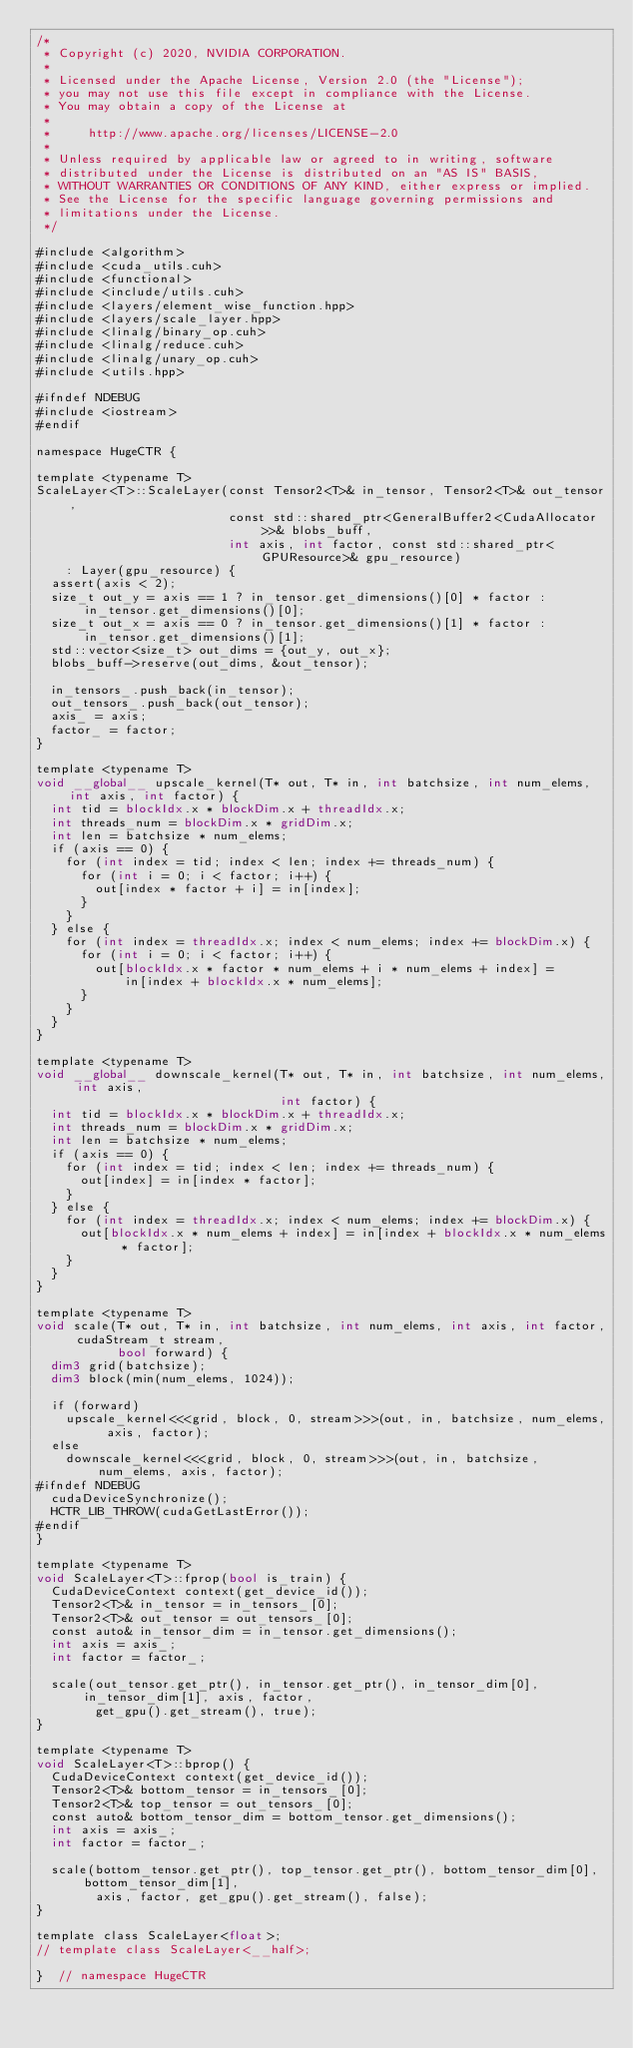Convert code to text. <code><loc_0><loc_0><loc_500><loc_500><_Cuda_>/*
 * Copyright (c) 2020, NVIDIA CORPORATION.
 *
 * Licensed under the Apache License, Version 2.0 (the "License");
 * you may not use this file except in compliance with the License.
 * You may obtain a copy of the License at
 *
 *     http://www.apache.org/licenses/LICENSE-2.0
 *
 * Unless required by applicable law or agreed to in writing, software
 * distributed under the License is distributed on an "AS IS" BASIS,
 * WITHOUT WARRANTIES OR CONDITIONS OF ANY KIND, either express or implied.
 * See the License for the specific language governing permissions and
 * limitations under the License.
 */

#include <algorithm>
#include <cuda_utils.cuh>
#include <functional>
#include <include/utils.cuh>
#include <layers/element_wise_function.hpp>
#include <layers/scale_layer.hpp>
#include <linalg/binary_op.cuh>
#include <linalg/reduce.cuh>
#include <linalg/unary_op.cuh>
#include <utils.hpp>

#ifndef NDEBUG
#include <iostream>
#endif

namespace HugeCTR {

template <typename T>
ScaleLayer<T>::ScaleLayer(const Tensor2<T>& in_tensor, Tensor2<T>& out_tensor,
                          const std::shared_ptr<GeneralBuffer2<CudaAllocator>>& blobs_buff,
                          int axis, int factor, const std::shared_ptr<GPUResource>& gpu_resource)
    : Layer(gpu_resource) {
  assert(axis < 2);
  size_t out_y = axis == 1 ? in_tensor.get_dimensions()[0] * factor : in_tensor.get_dimensions()[0];
  size_t out_x = axis == 0 ? in_tensor.get_dimensions()[1] * factor : in_tensor.get_dimensions()[1];
  std::vector<size_t> out_dims = {out_y, out_x};
  blobs_buff->reserve(out_dims, &out_tensor);

  in_tensors_.push_back(in_tensor);
  out_tensors_.push_back(out_tensor);
  axis_ = axis;
  factor_ = factor;
}

template <typename T>
void __global__ upscale_kernel(T* out, T* in, int batchsize, int num_elems, int axis, int factor) {
  int tid = blockIdx.x * blockDim.x + threadIdx.x;
  int threads_num = blockDim.x * gridDim.x;
  int len = batchsize * num_elems;
  if (axis == 0) {
    for (int index = tid; index < len; index += threads_num) {
      for (int i = 0; i < factor; i++) {
        out[index * factor + i] = in[index];
      }
    }
  } else {
    for (int index = threadIdx.x; index < num_elems; index += blockDim.x) {
      for (int i = 0; i < factor; i++) {
        out[blockIdx.x * factor * num_elems + i * num_elems + index] =
            in[index + blockIdx.x * num_elems];
      }
    }
  }
}

template <typename T>
void __global__ downscale_kernel(T* out, T* in, int batchsize, int num_elems, int axis,
                                 int factor) {
  int tid = blockIdx.x * blockDim.x + threadIdx.x;
  int threads_num = blockDim.x * gridDim.x;
  int len = batchsize * num_elems;
  if (axis == 0) {
    for (int index = tid; index < len; index += threads_num) {
      out[index] = in[index * factor];
    }
  } else {
    for (int index = threadIdx.x; index < num_elems; index += blockDim.x) {
      out[blockIdx.x * num_elems + index] = in[index + blockIdx.x * num_elems * factor];
    }
  }
}

template <typename T>
void scale(T* out, T* in, int batchsize, int num_elems, int axis, int factor, cudaStream_t stream,
           bool forward) {
  dim3 grid(batchsize);
  dim3 block(min(num_elems, 1024));

  if (forward)
    upscale_kernel<<<grid, block, 0, stream>>>(out, in, batchsize, num_elems, axis, factor);
  else
    downscale_kernel<<<grid, block, 0, stream>>>(out, in, batchsize, num_elems, axis, factor);
#ifndef NDEBUG
  cudaDeviceSynchronize();
  HCTR_LIB_THROW(cudaGetLastError());
#endif
}

template <typename T>
void ScaleLayer<T>::fprop(bool is_train) {
  CudaDeviceContext context(get_device_id());
  Tensor2<T>& in_tensor = in_tensors_[0];
  Tensor2<T>& out_tensor = out_tensors_[0];
  const auto& in_tensor_dim = in_tensor.get_dimensions();
  int axis = axis_;
  int factor = factor_;

  scale(out_tensor.get_ptr(), in_tensor.get_ptr(), in_tensor_dim[0], in_tensor_dim[1], axis, factor,
        get_gpu().get_stream(), true);
}

template <typename T>
void ScaleLayer<T>::bprop() {
  CudaDeviceContext context(get_device_id());
  Tensor2<T>& bottom_tensor = in_tensors_[0];
  Tensor2<T>& top_tensor = out_tensors_[0];
  const auto& bottom_tensor_dim = bottom_tensor.get_dimensions();
  int axis = axis_;
  int factor = factor_;

  scale(bottom_tensor.get_ptr(), top_tensor.get_ptr(), bottom_tensor_dim[0], bottom_tensor_dim[1],
        axis, factor, get_gpu().get_stream(), false);
}

template class ScaleLayer<float>;
// template class ScaleLayer<__half>;

}  // namespace HugeCTR
</code> 